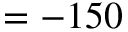<formula> <loc_0><loc_0><loc_500><loc_500>= - 1 5 0</formula> 